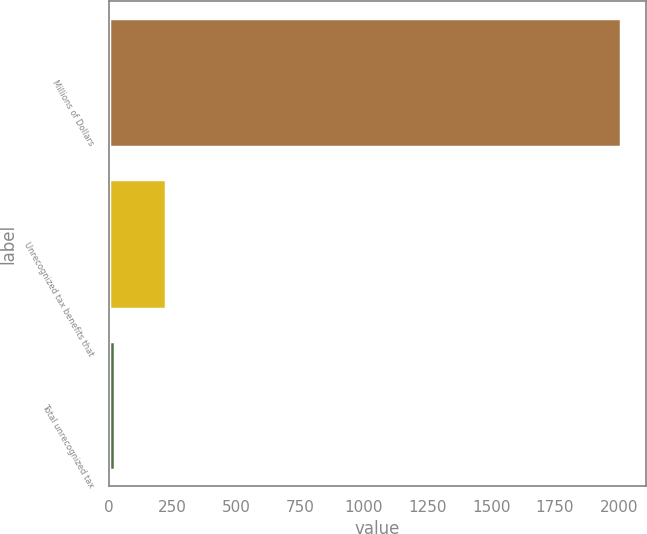<chart> <loc_0><loc_0><loc_500><loc_500><bar_chart><fcel>Millions of Dollars<fcel>Unrecognized tax benefits that<fcel>Total unrecognized tax<nl><fcel>2008<fcel>224.2<fcel>26<nl></chart> 